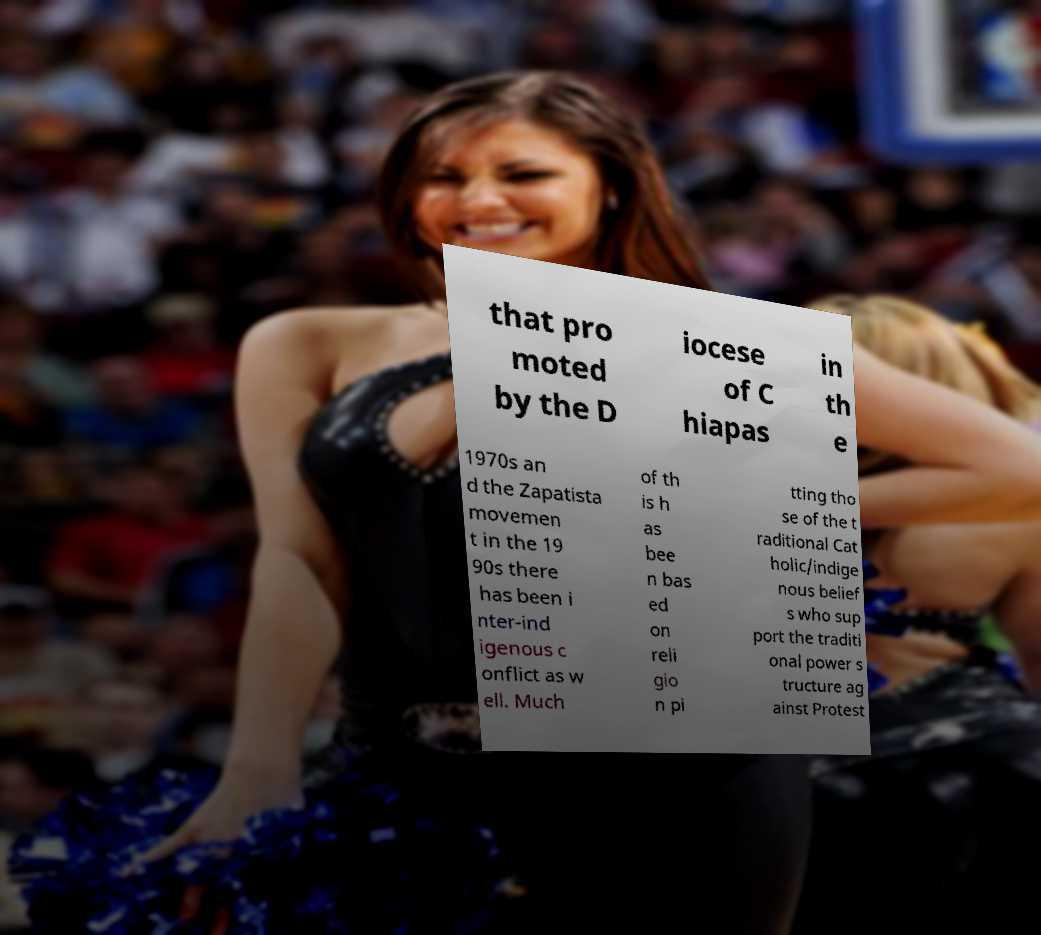I need the written content from this picture converted into text. Can you do that? that pro moted by the D iocese of C hiapas in th e 1970s an d the Zapatista movemen t in the 19 90s there has been i nter-ind igenous c onflict as w ell. Much of th is h as bee n bas ed on reli gio n pi tting tho se of the t raditional Cat holic/indige nous belief s who sup port the traditi onal power s tructure ag ainst Protest 